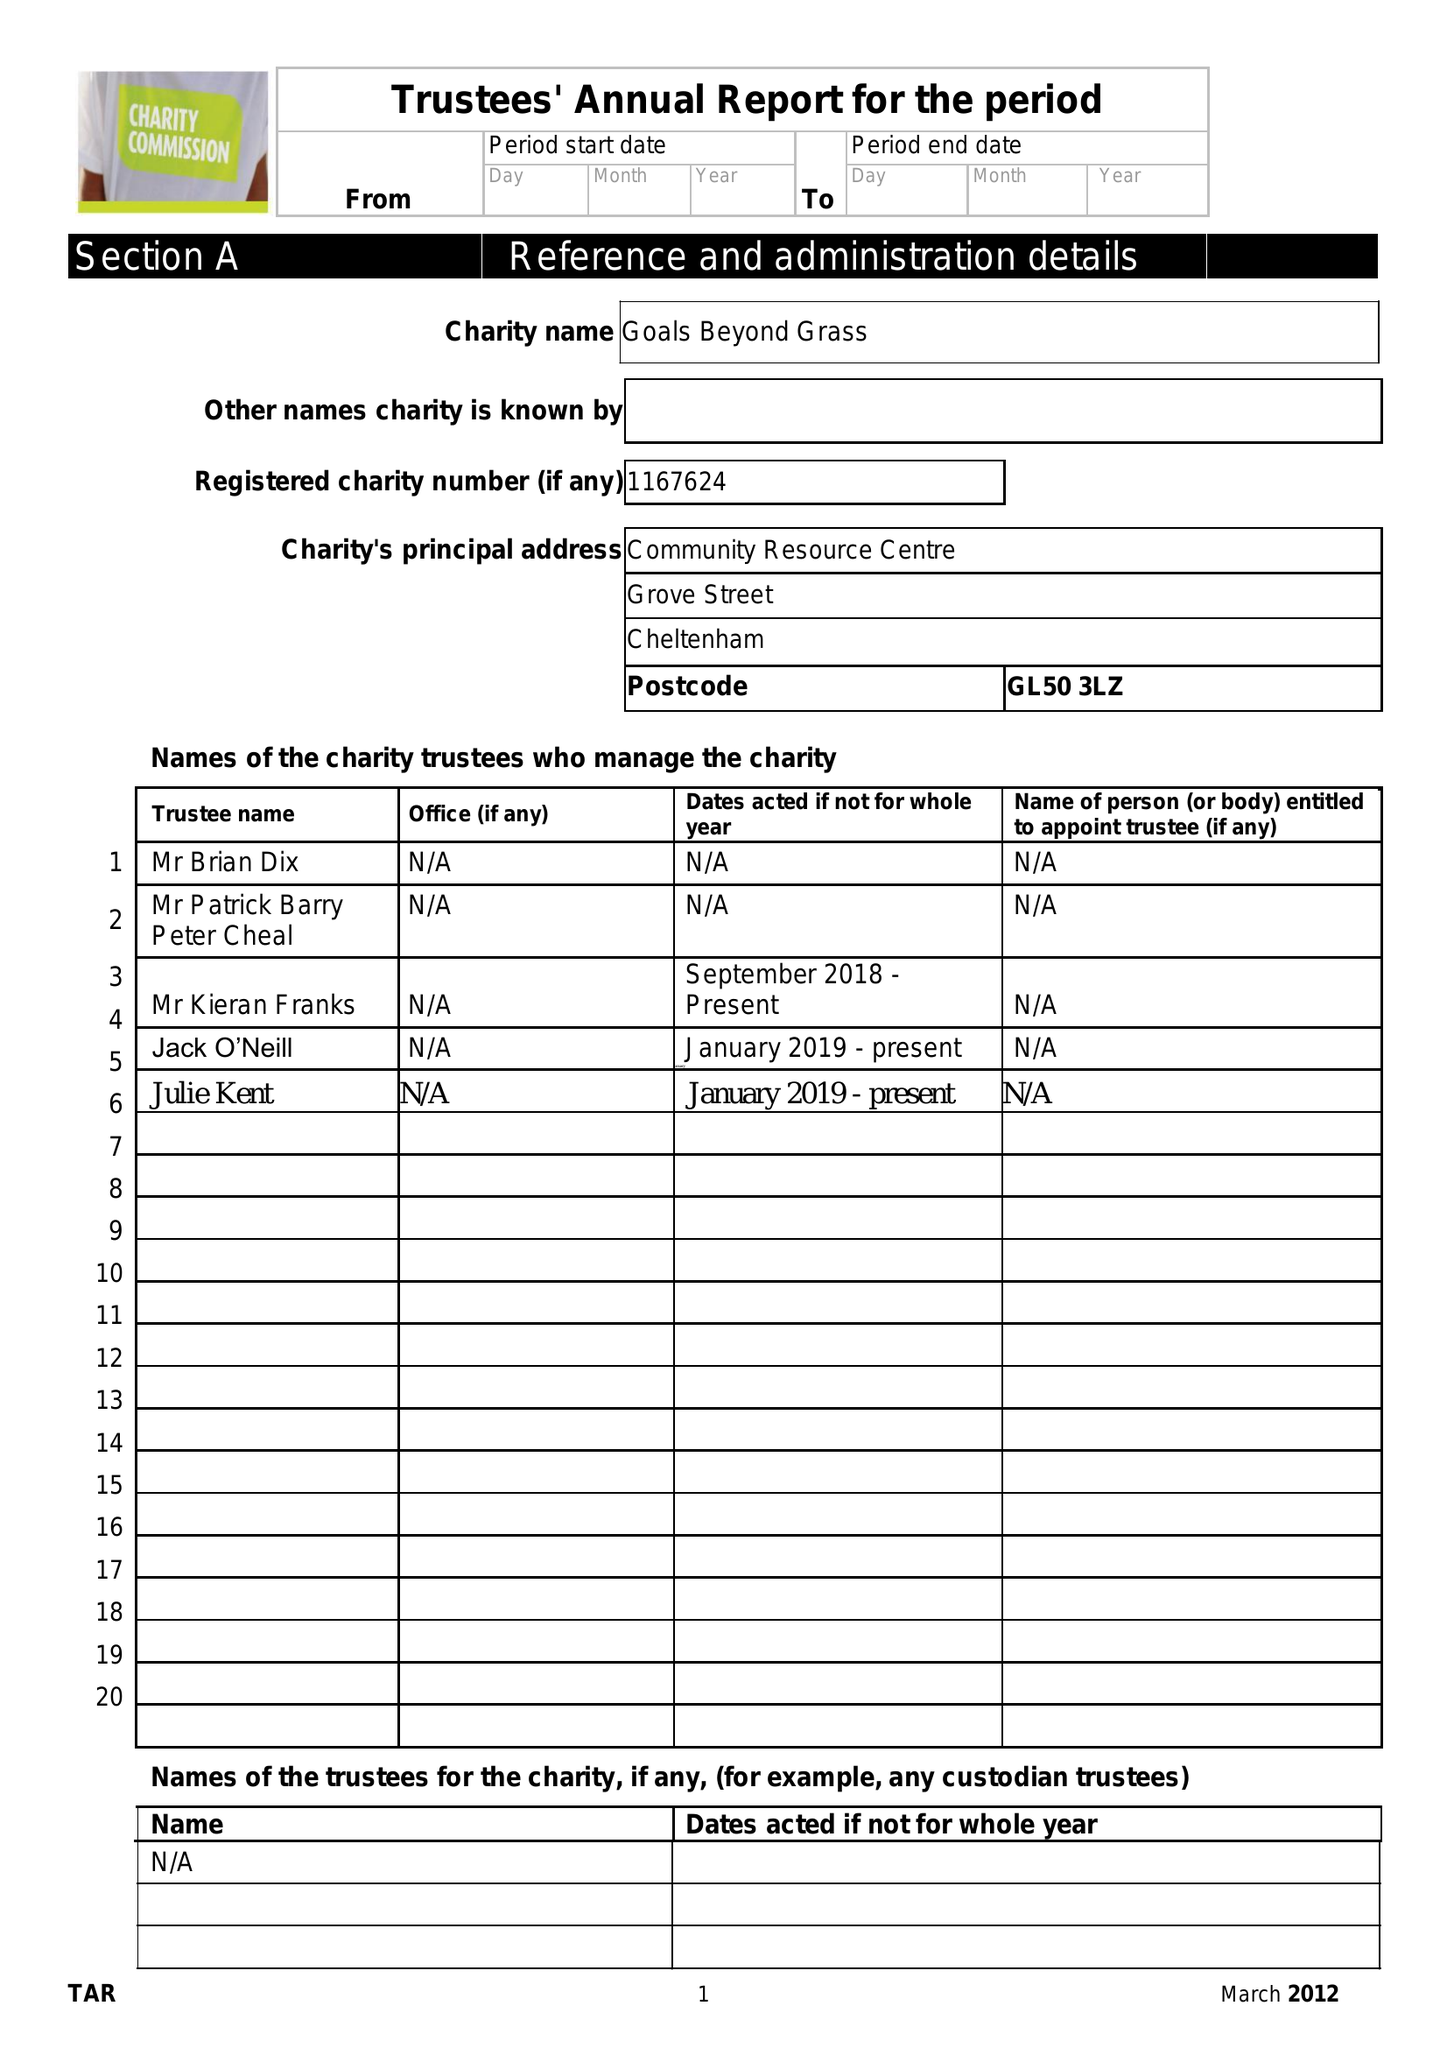What is the value for the address__postcode?
Answer the question using a single word or phrase. GL1 3NU 